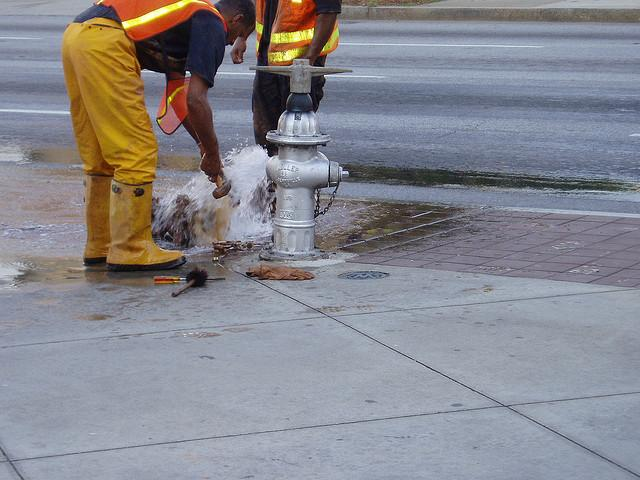Who caused the water to flood out?

Choices:
A) mayor
B) fireman
C) vandal
D) these men these men 